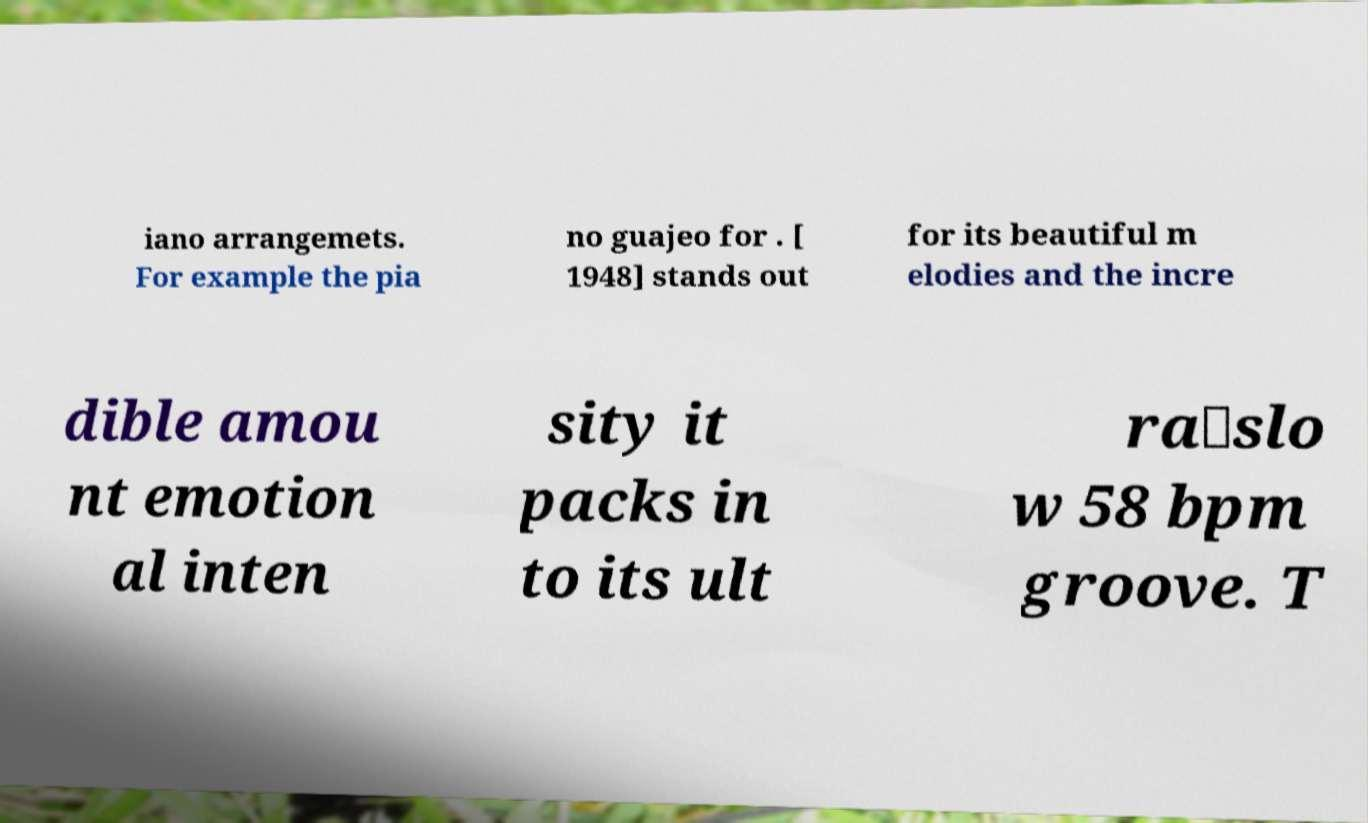For documentation purposes, I need the text within this image transcribed. Could you provide that? iano arrangemets. For example the pia no guajeo for . [ 1948] stands out for its beautiful m elodies and the incre dible amou nt emotion al inten sity it packs in to its ult ra‐slo w 58 bpm groove. T 